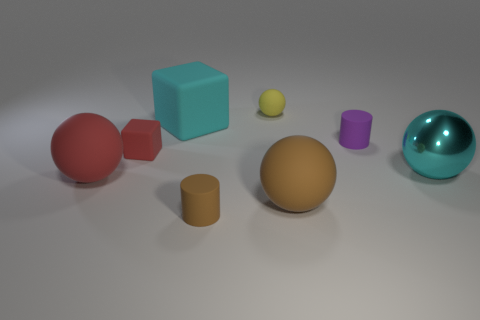Subtract all cyan spheres. How many spheres are left? 3 Add 1 tiny brown rubber things. How many objects exist? 9 Subtract all green spheres. Subtract all cyan blocks. How many spheres are left? 4 Subtract all blocks. How many objects are left? 6 Subtract all small matte balls. Subtract all matte things. How many objects are left? 0 Add 6 small brown rubber objects. How many small brown rubber objects are left? 7 Add 2 big brown matte spheres. How many big brown matte spheres exist? 3 Subtract 1 cyan balls. How many objects are left? 7 